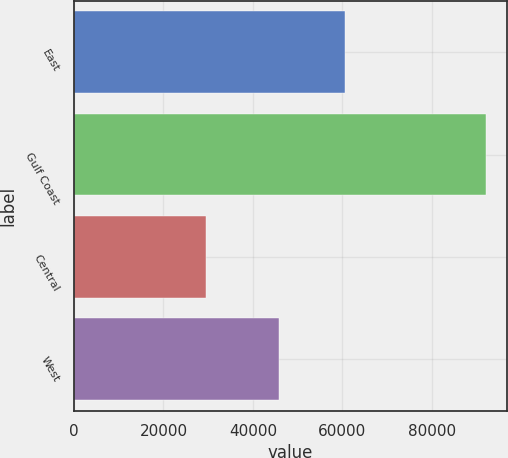Convert chart to OTSL. <chart><loc_0><loc_0><loc_500><loc_500><bar_chart><fcel>East<fcel>Gulf Coast<fcel>Central<fcel>West<nl><fcel>60494<fcel>92095<fcel>29597<fcel>45770<nl></chart> 